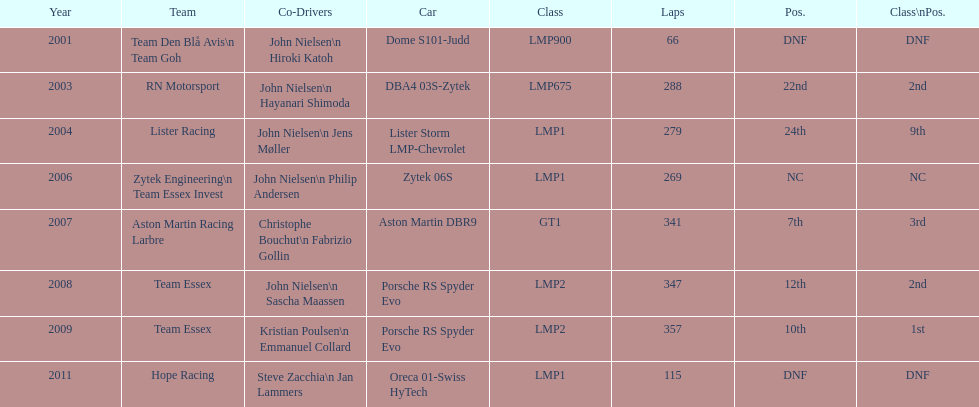In how many cases was the ultimate position over 20? 2. 